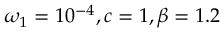Convert formula to latex. <formula><loc_0><loc_0><loc_500><loc_500>\omega _ { 1 } = 1 0 ^ { - 4 } , c = 1 , \beta = 1 . 2</formula> 